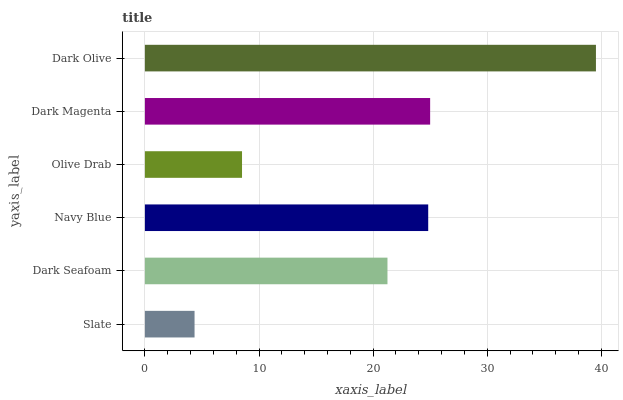Is Slate the minimum?
Answer yes or no. Yes. Is Dark Olive the maximum?
Answer yes or no. Yes. Is Dark Seafoam the minimum?
Answer yes or no. No. Is Dark Seafoam the maximum?
Answer yes or no. No. Is Dark Seafoam greater than Slate?
Answer yes or no. Yes. Is Slate less than Dark Seafoam?
Answer yes or no. Yes. Is Slate greater than Dark Seafoam?
Answer yes or no. No. Is Dark Seafoam less than Slate?
Answer yes or no. No. Is Navy Blue the high median?
Answer yes or no. Yes. Is Dark Seafoam the low median?
Answer yes or no. Yes. Is Dark Seafoam the high median?
Answer yes or no. No. Is Dark Olive the low median?
Answer yes or no. No. 